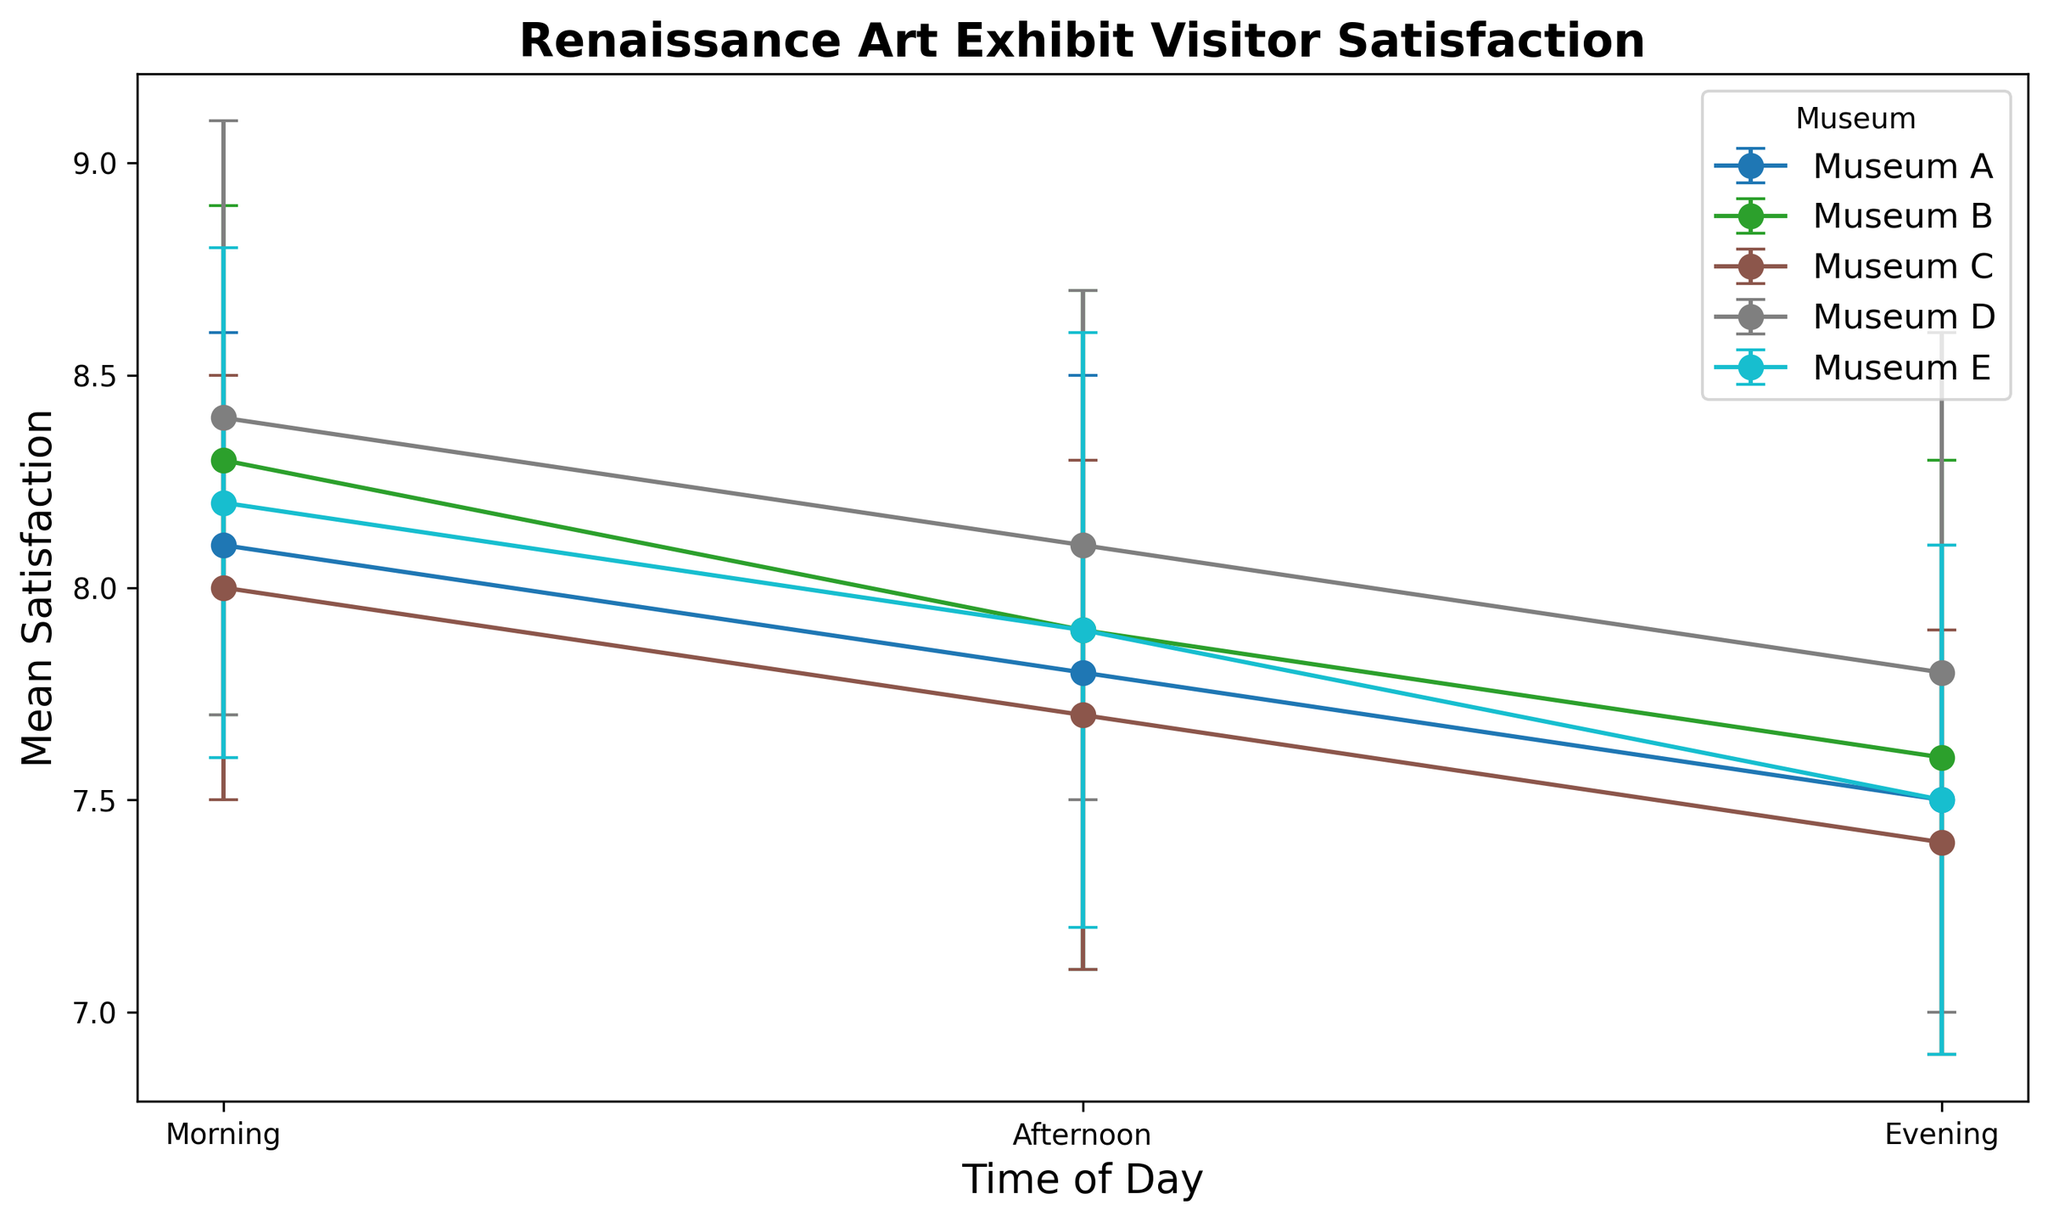What time of day has the highest mean satisfaction for Museum D? To find the answer, look at the data points for Museum D and identify which time of day has the highest mean satisfaction value. The points for Museum D are plotted with error bars: Morning (8.4), Afternoon (8.1), and Evening (7.8). Morning has the highest value.
Answer: Morning How does the mean satisfaction in the morning compare between Museum A and Museum E? Compare the mean satisfaction values for the morning at Museum A (8.1) and Museum E (8.2). Museum E's mean satisfaction is slightly higher.
Answer: Museum E is higher Which museum has the lowest mean satisfaction in the evening, and what is that value? Look at the evening data for all museums: Museum A (7.5), Museum B (7.6), Museum C (7.4), Museum D (7.8), and Museum E (7.5). Museum C has the lowest mean satisfaction value of 7.4 in the evening.
Answer: Museum C, 7.4 What is the difference in mean satisfaction between the morning and evening for Museum B? Find the difference in mean satisfaction for Museum B in the morning (8.3) and evening (7.6). The calculation is 8.3 - 7.6 = 0.7.
Answer: 0.7 Which time of day has the smallest standard deviation in mean satisfaction for all museums, and what is that value? Compare the standard deviations for each time of day across all museums: Morning (A: 0.5, B: 0.6, C: 0.5, D: 0.7, E: 0.6), Afternoon (A: 0.7, B: 0.8, C: 0.6, D: 0.6, E: 0.7), Evening (A: 0.6, B: 0.7, C: 0.5, D: 0.8, E: 0.6). The smallest standard deviation is in the morning for Museum A, which is 0.5.
Answer: Morning, 0.5 Among all the museums, which one shows the most consistent visitor satisfaction (smallest range of standard deviation) across all times of day? Calculate the range of standard deviations for each museum by subtracting the smallest standard deviation from the largest for each museum: Museum A (0.7 - 0.5), Museum B (0.8 - 0.6), Museum C (0.6 - 0.5), Museum D (0.8 - 0.6), Museum E (0.7 - 0.6). Museum C has the smallest range (0.6 - 0.5 = 0.1).
Answer: Museum C 